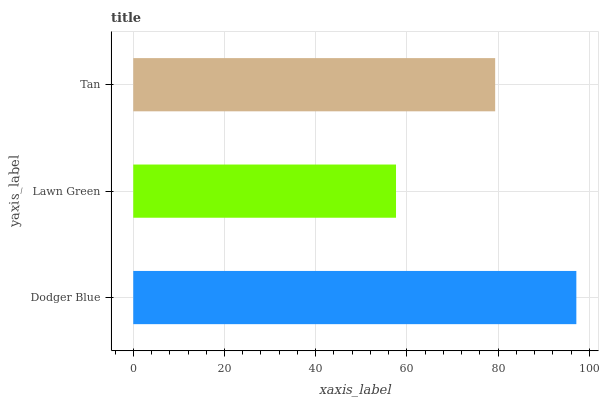Is Lawn Green the minimum?
Answer yes or no. Yes. Is Dodger Blue the maximum?
Answer yes or no. Yes. Is Tan the minimum?
Answer yes or no. No. Is Tan the maximum?
Answer yes or no. No. Is Tan greater than Lawn Green?
Answer yes or no. Yes. Is Lawn Green less than Tan?
Answer yes or no. Yes. Is Lawn Green greater than Tan?
Answer yes or no. No. Is Tan less than Lawn Green?
Answer yes or no. No. Is Tan the high median?
Answer yes or no. Yes. Is Tan the low median?
Answer yes or no. Yes. Is Dodger Blue the high median?
Answer yes or no. No. Is Dodger Blue the low median?
Answer yes or no. No. 